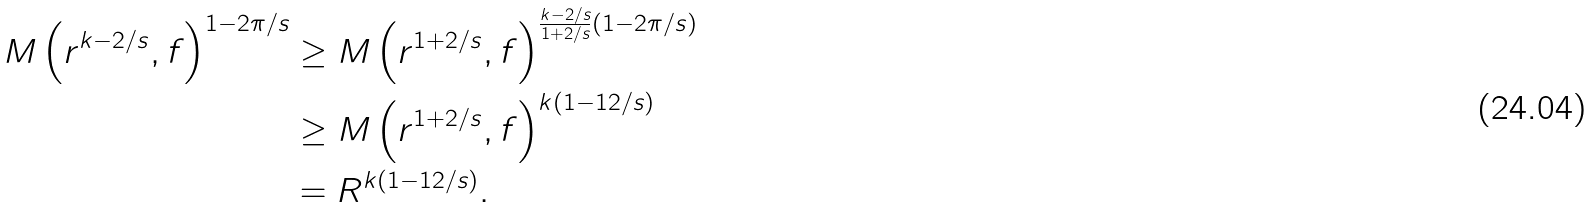<formula> <loc_0><loc_0><loc_500><loc_500>M \left ( r ^ { k - 2 / s } , f \right ) ^ { 1 - 2 \pi / s } & \geq M \left ( r ^ { 1 + 2 / s } , f \right ) ^ { \frac { k - 2 / s } { 1 + 2 / s } ( 1 - 2 \pi / s ) } \\ & \geq M \left ( r ^ { 1 + 2 / s } , f \right ) ^ { k ( 1 - 1 2 / s ) } \\ & = R ^ { k ( 1 - 1 2 / s ) } .</formula> 